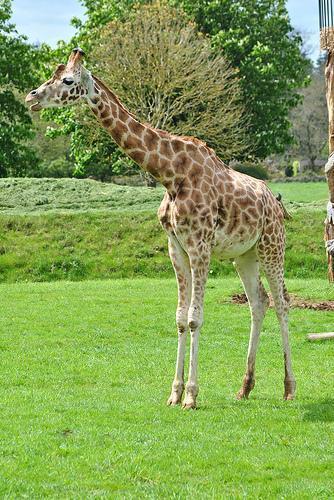How many giraffes at the park?
Give a very brief answer. 1. 